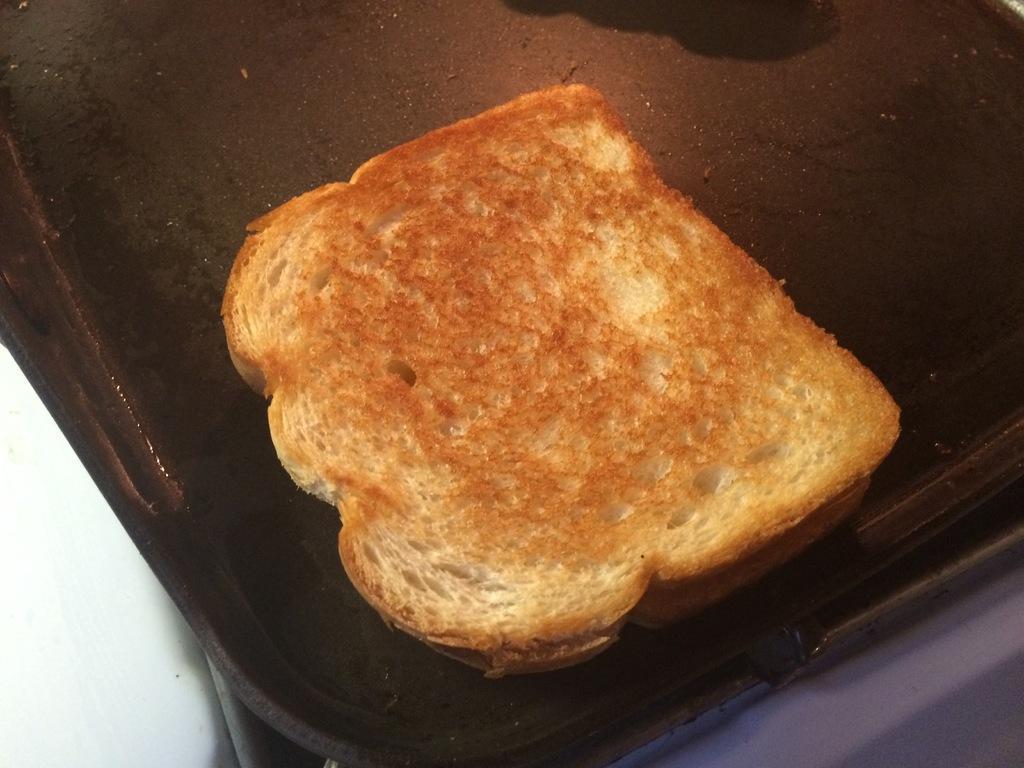Please provide a concise description of this image. In this image we can see a tray with bread on the table. 